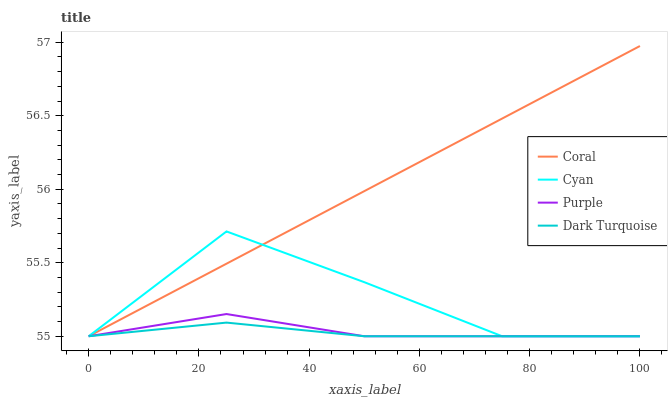Does Dark Turquoise have the minimum area under the curve?
Answer yes or no. Yes. Does Coral have the maximum area under the curve?
Answer yes or no. Yes. Does Cyan have the minimum area under the curve?
Answer yes or no. No. Does Cyan have the maximum area under the curve?
Answer yes or no. No. Is Coral the smoothest?
Answer yes or no. Yes. Is Cyan the roughest?
Answer yes or no. Yes. Is Cyan the smoothest?
Answer yes or no. No. Is Coral the roughest?
Answer yes or no. No. Does Coral have the highest value?
Answer yes or no. Yes. Does Cyan have the highest value?
Answer yes or no. No. Does Purple intersect Coral?
Answer yes or no. Yes. Is Purple less than Coral?
Answer yes or no. No. Is Purple greater than Coral?
Answer yes or no. No. 